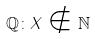Convert formula to latex. <formula><loc_0><loc_0><loc_500><loc_500>\mathbb { Q } \colon X \notin \mathbb { N }</formula> 